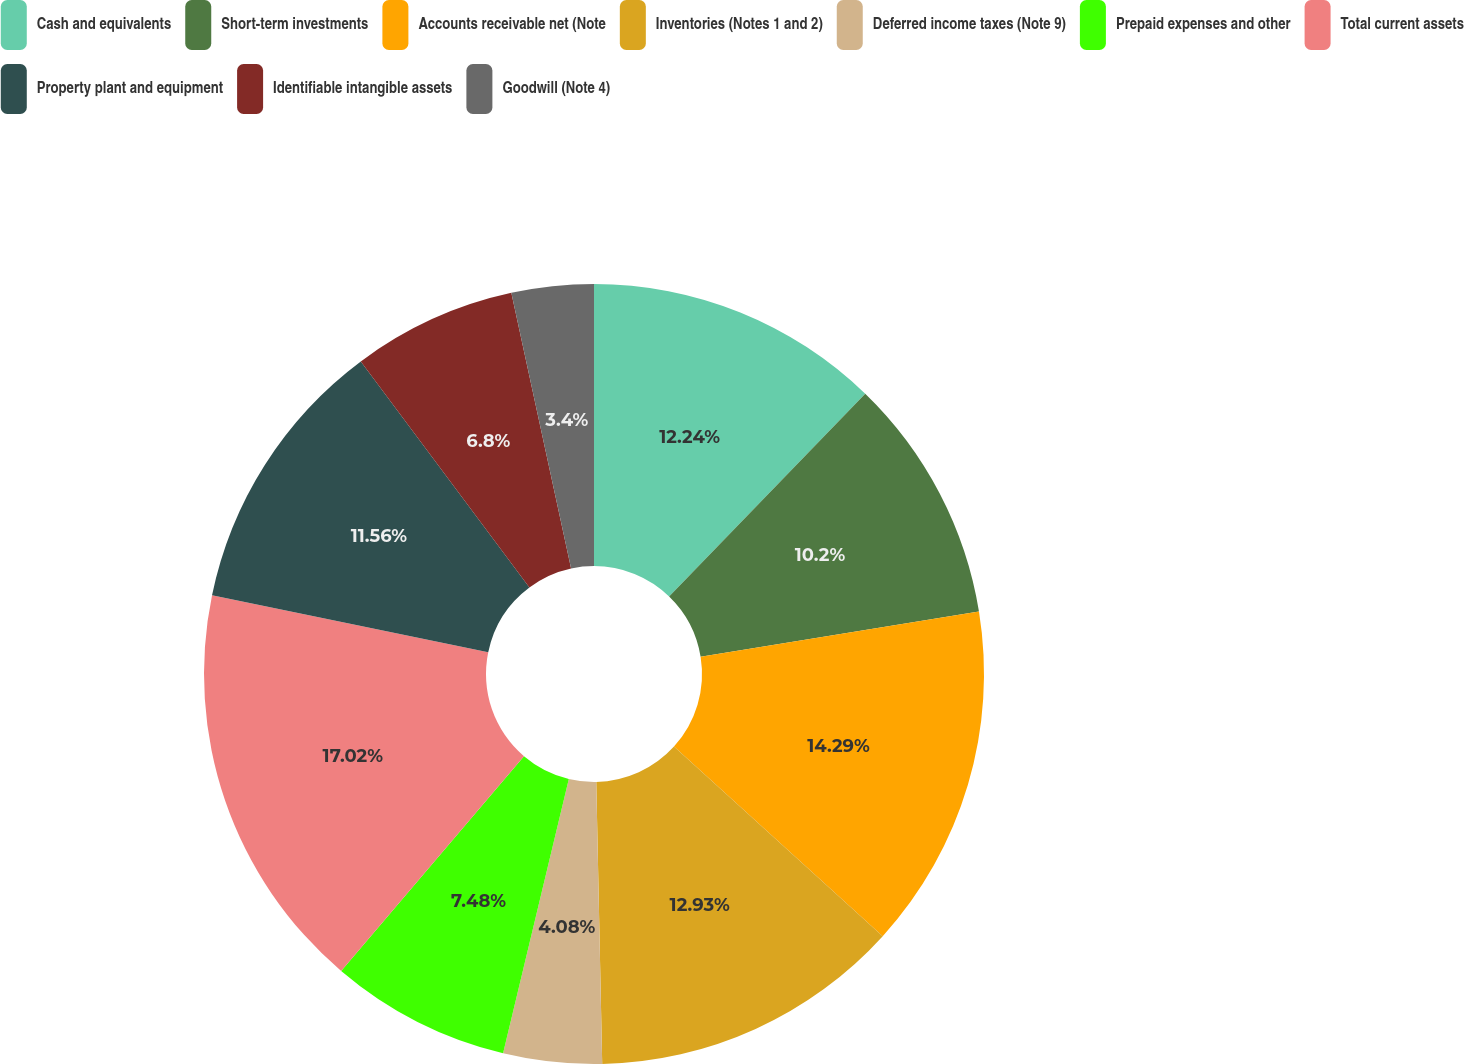<chart> <loc_0><loc_0><loc_500><loc_500><pie_chart><fcel>Cash and equivalents<fcel>Short-term investments<fcel>Accounts receivable net (Note<fcel>Inventories (Notes 1 and 2)<fcel>Deferred income taxes (Note 9)<fcel>Prepaid expenses and other<fcel>Total current assets<fcel>Property plant and equipment<fcel>Identifiable intangible assets<fcel>Goodwill (Note 4)<nl><fcel>12.24%<fcel>10.2%<fcel>14.29%<fcel>12.93%<fcel>4.08%<fcel>7.48%<fcel>17.01%<fcel>11.56%<fcel>6.8%<fcel>3.4%<nl></chart> 